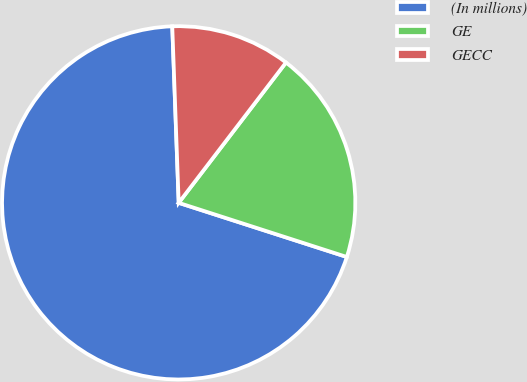Convert chart to OTSL. <chart><loc_0><loc_0><loc_500><loc_500><pie_chart><fcel>(In millions)<fcel>GE<fcel>GECC<nl><fcel>69.46%<fcel>19.57%<fcel>10.97%<nl></chart> 